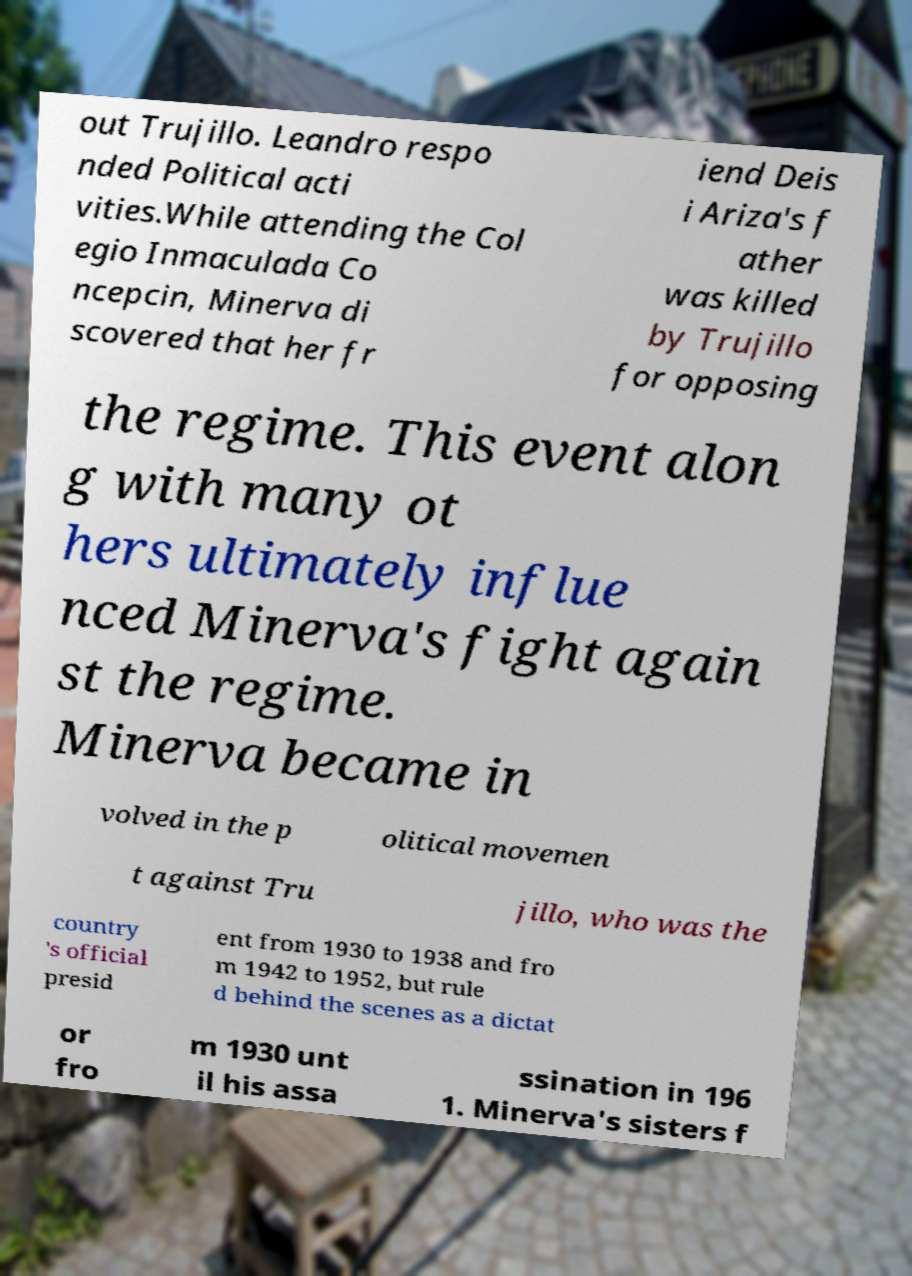Please read and relay the text visible in this image. What does it say? out Trujillo. Leandro respo nded Political acti vities.While attending the Col egio Inmaculada Co ncepcin, Minerva di scovered that her fr iend Deis i Ariza's f ather was killed by Trujillo for opposing the regime. This event alon g with many ot hers ultimately influe nced Minerva's fight again st the regime. Minerva became in volved in the p olitical movemen t against Tru jillo, who was the country 's official presid ent from 1930 to 1938 and fro m 1942 to 1952, but rule d behind the scenes as a dictat or fro m 1930 unt il his assa ssination in 196 1. Minerva's sisters f 